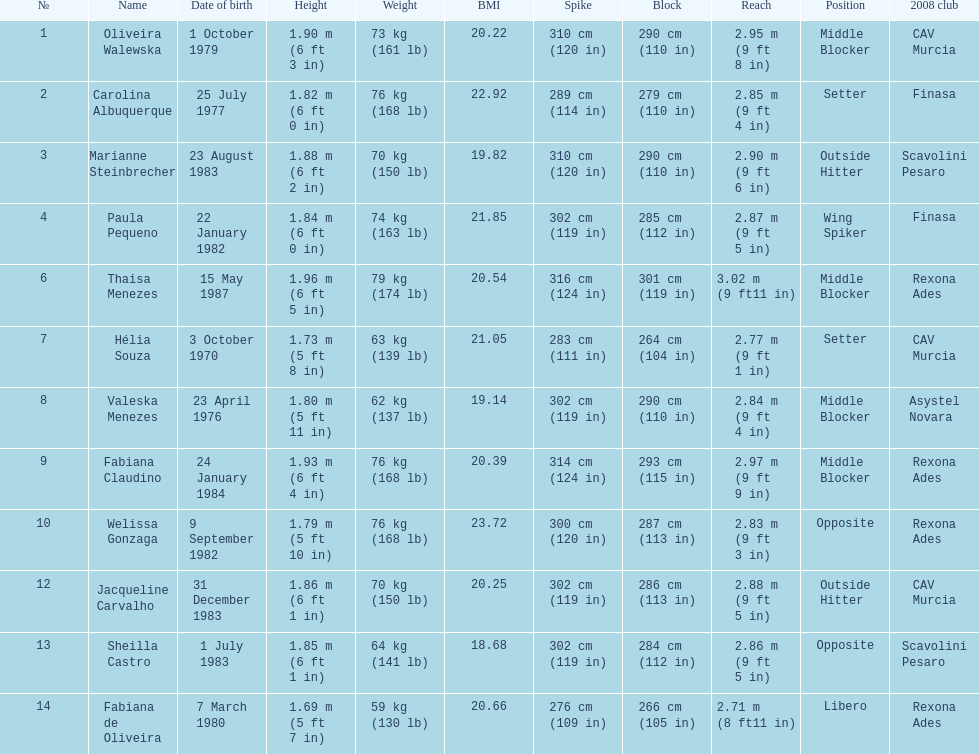Oliveira walewska has the same block as how many other players? 2. 